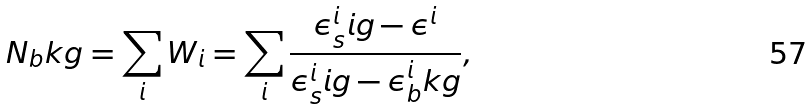<formula> <loc_0><loc_0><loc_500><loc_500>N _ { b } k g = \sum _ { i } W _ { i } = \sum _ { i } \frac { \epsilon ^ { i } _ { s } i g - \epsilon ^ { i } } { \epsilon ^ { i } _ { s } i g - \epsilon ^ { i } _ { b } k g } ,</formula> 